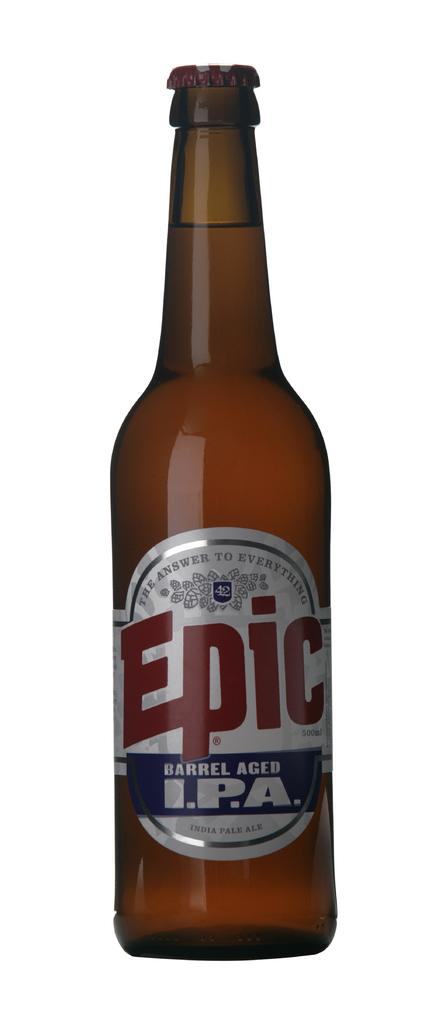What object can be seen in the image? There is a bottle in the image. What is written on the bottle? The bottle has the brand name "epic" written on it. What type of hope can be seen in the image? There is no hope present in the image; it only features a bottle with the brand name "epic" written on it. 